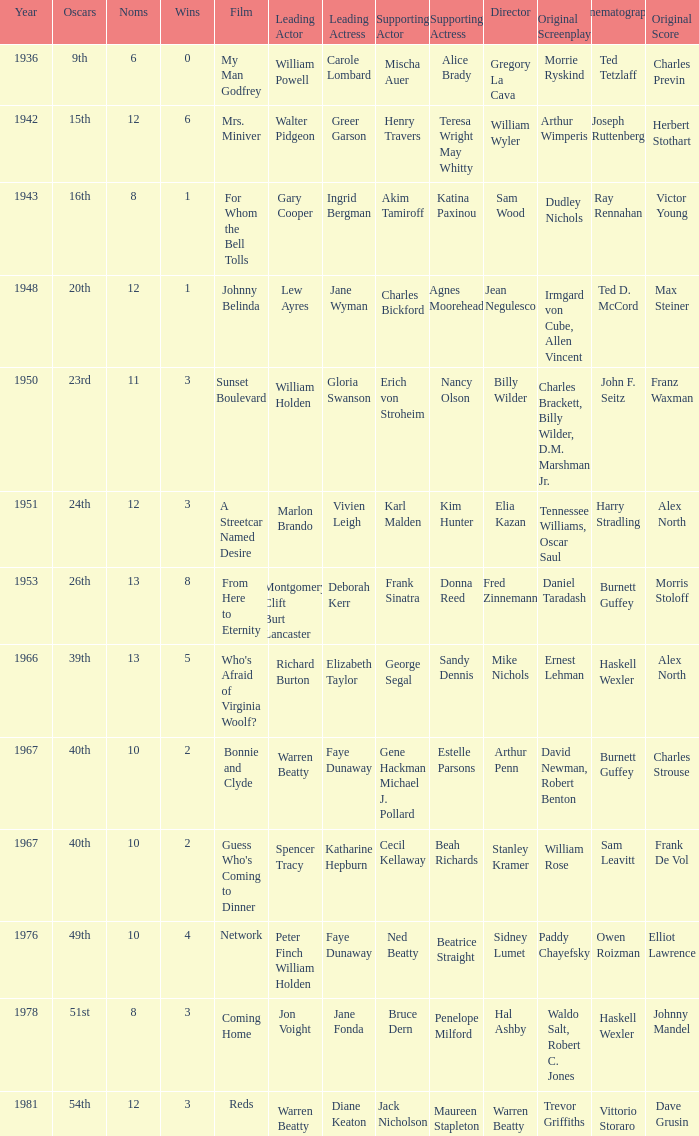Who was the supporting actress in 1943? Katina Paxinou. 